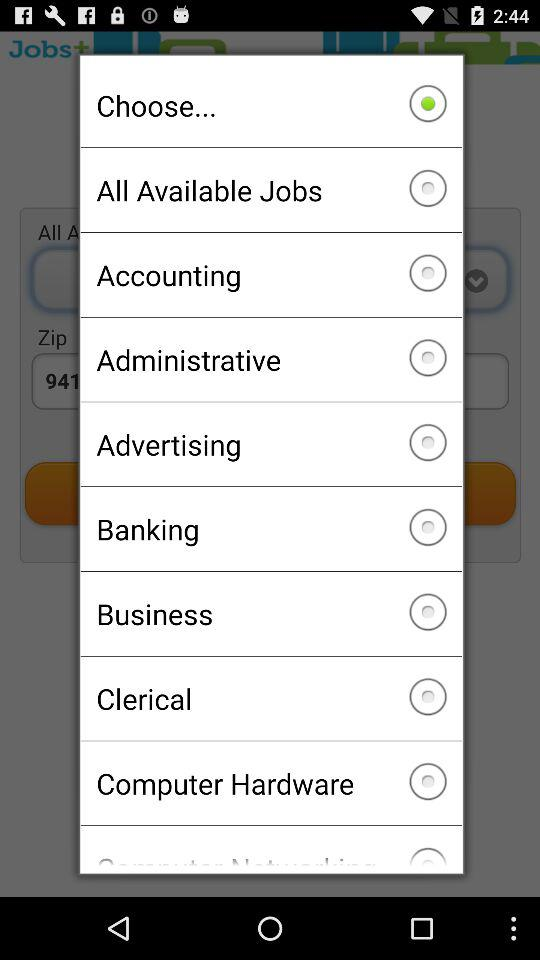What kind of job should you get?
When the provided information is insufficient, respond with <no answer>. <no answer> 